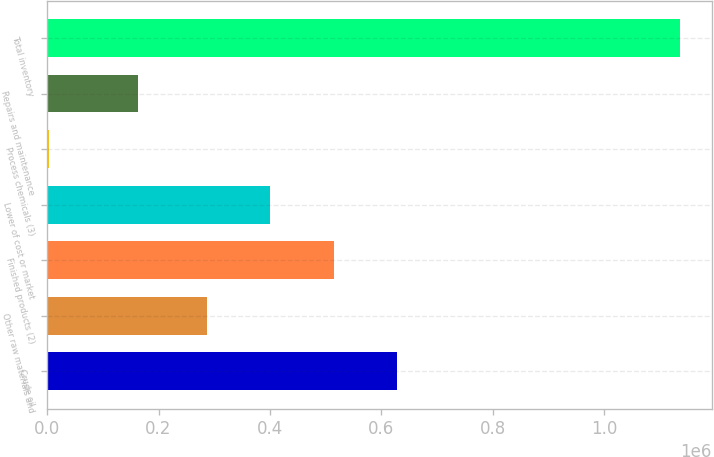Convert chart. <chart><loc_0><loc_0><loc_500><loc_500><bar_chart><fcel>Crude oil<fcel>Other raw materials and<fcel>Finished products (2)<fcel>Lower of cost or market<fcel>Process chemicals (3)<fcel>Repairs and maintenance<fcel>Total inventory<nl><fcel>627434<fcel>287561<fcel>514143<fcel>400852<fcel>2767<fcel>162548<fcel>1.13568e+06<nl></chart> 